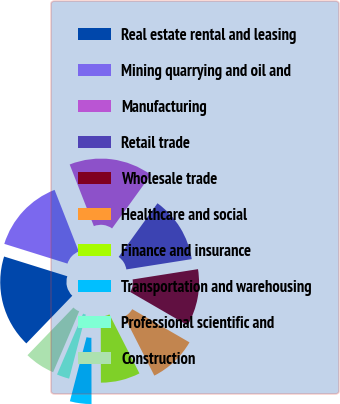Convert chart to OTSL. <chart><loc_0><loc_0><loc_500><loc_500><pie_chart><fcel>Real estate rental and leasing<fcel>Mining quarrying and oil and<fcel>Manufacturing<fcel>Retail trade<fcel>Wholesale trade<fcel>Healthcare and social<fcel>Finance and insurance<fcel>Transportation and warehousing<fcel>Professional scientific and<fcel>Construction<nl><fcel>17.61%<fcel>14.23%<fcel>15.92%<fcel>12.54%<fcel>10.85%<fcel>9.15%<fcel>7.46%<fcel>4.08%<fcel>2.39%<fcel>5.77%<nl></chart> 